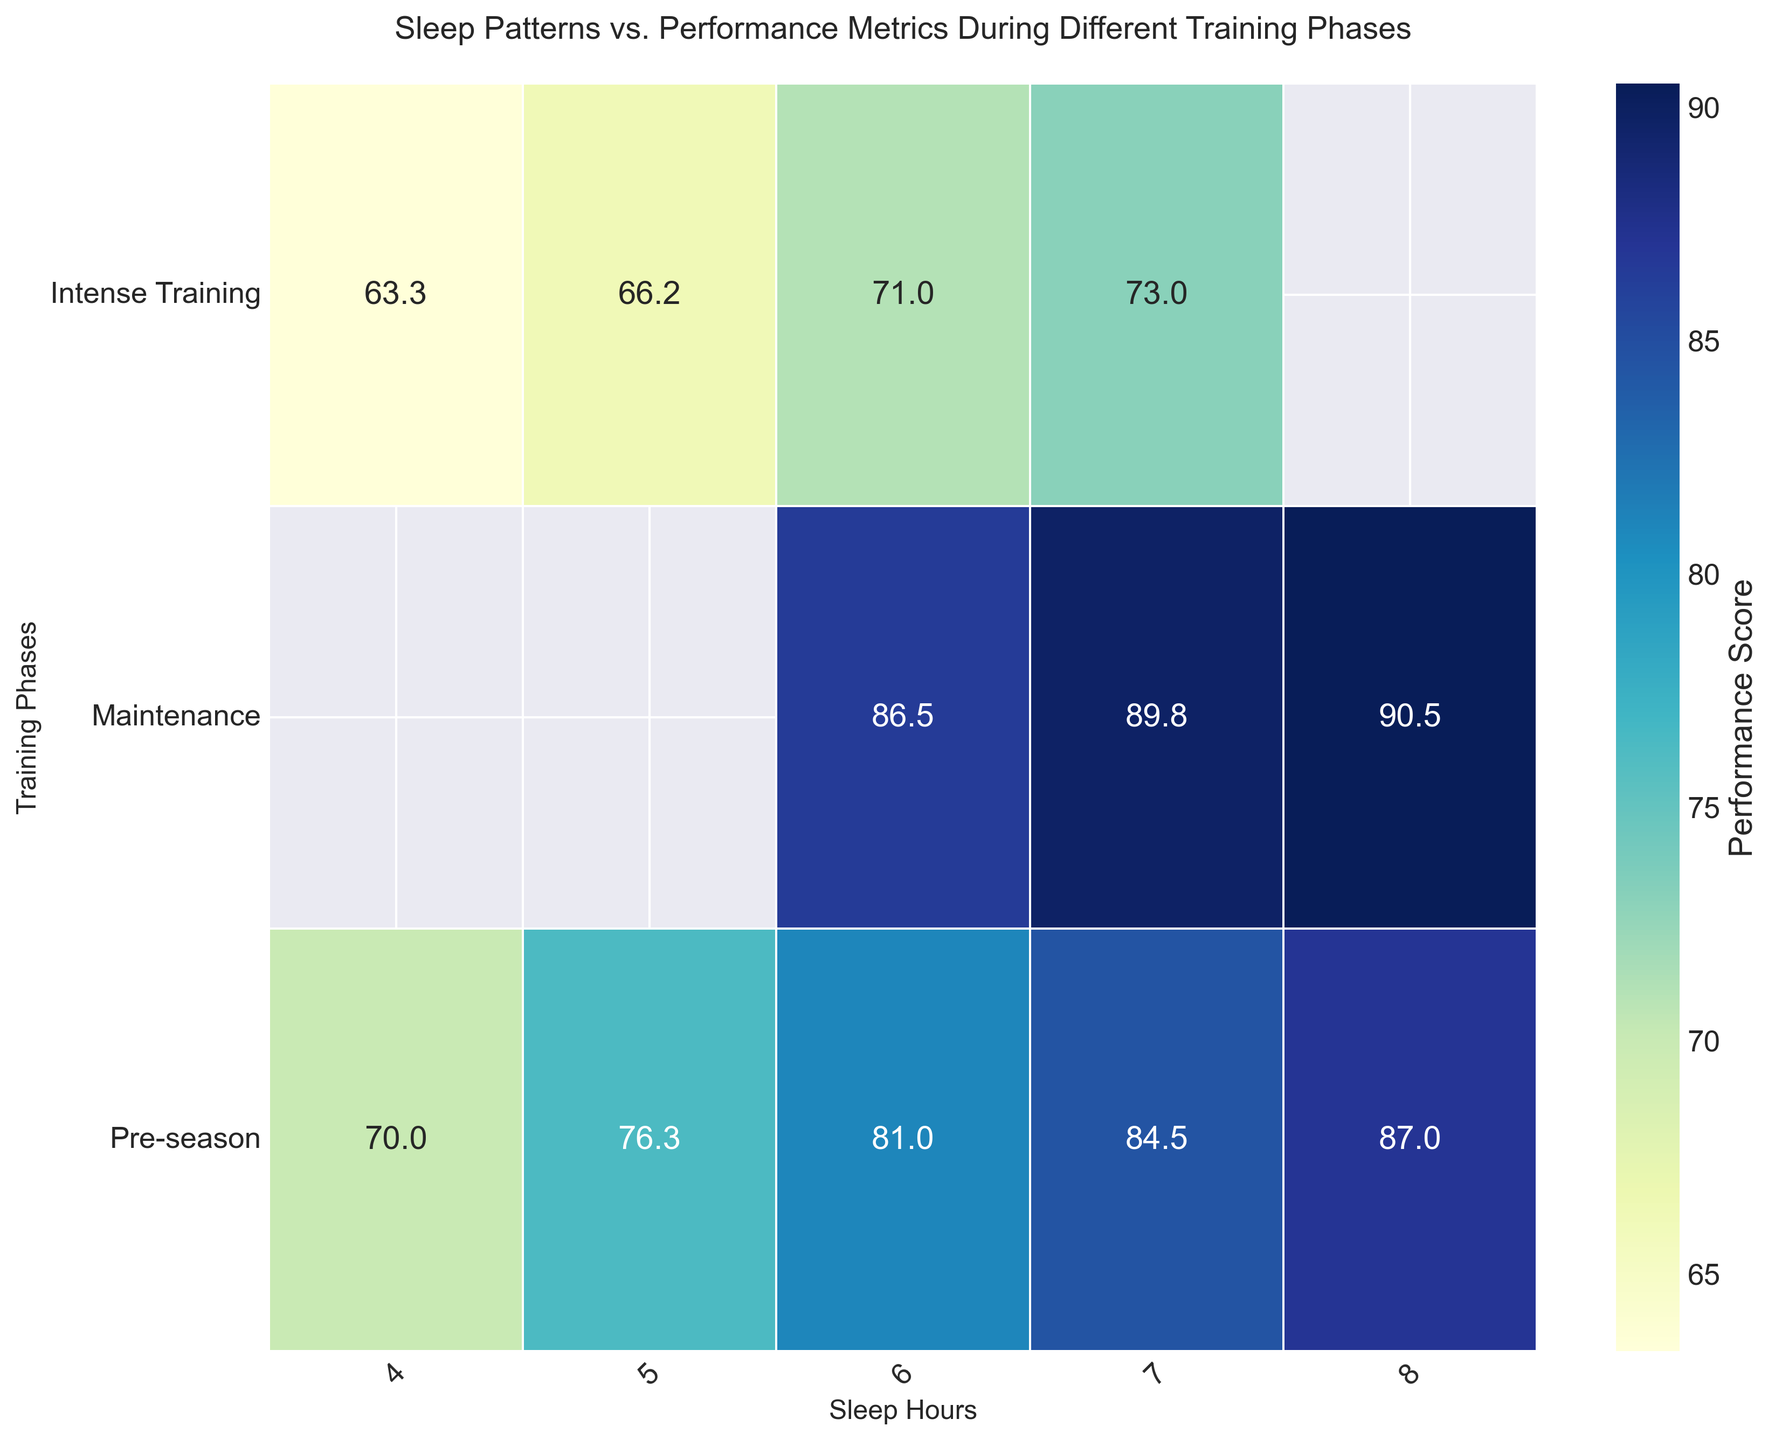How does the performance score change with sleep hours during the pre-season phase? During the pre-season phase, the performance score tends to increase with more sleep. For example, at 5 hours of sleep, the performance score is around 76.0, at 6 hours it increases to about 80.8, and at 7 hours it further increases to 84.5.
Answer: It increases Which phase has the highest average performance score at 7 hours of sleep? By looking at the heatmap, the maintenance phase has the highest performance score at 7 hours of sleep with a value of 89.8. In comparison, the pre-season score at 7 hours is 84.5, and intense training is 73.0.
Answer: Maintenance Compare the performance scores for 6 hours of sleep across different training phases. In the heatmap, pre-season has a score of 80.8, intense training has a score of 67.5, and maintenance has a score of 86.5 for 6 hours of sleep. Comparing these scores, maintenance is the highest, followed by pre-season, and intense training has the lowest score.
Answer: Maintenance > Pre-season > Intense Training What is the average performance score during the intense training phase? To calculate the average for the intense training phase, add the performance scores for different sleep hours (4 hours = 63.3, 5 hours = 66.3, 6 hours = 67.5, 7 hours = 73.0) and divide by the number of data points: (63.3 + 66.3 + 67.5 + 73.0)/4 = 67.5
Answer: 67.5 During which phase and at how many hours of sleep does the highest performance score occur? The highest performance score is 90.8, which is observed during the maintenance phase at 8 hours of sleep. This can be deduced from the darkest colored cell in the heatmap with the highest annotation.
Answer: Maintenance at 8 hours Is there any phase where a lower number of sleep hours correlates with a higher performance score than a higher number of sleep hours within the same phase? No, in all phases, an increase in sleep hours is associated with an increase or at least consistent higher performance scores. For example, in intense training, performance scores increase from 63.3 at 4 hours to 73.0 at 7 hours.
Answer: No Compare the visual intensity of the color for 6 hours of sleep across all the phases. Which phase stands out and why? The color intensity for 6 hours of sleep is darkest in the maintenance phase, indicating the highest performance score (86.5). In comparison, the pre-season phase has a moderate intensity (80.8), and the intense training phase has the lightest color (67.5), indicating the lowest performance score.
Answer: Maintenance stands out due to the darkest color indicating the highest performance score Identify the trend of performance scores for the maintenance phase as sleep increases from 6 to 8 hours. The performance scores in the maintenance phase show an increasing trend with sleep: at 6 hours the score is 86.5, at 7 hours it is 89.8, and at 8 hours it reaches 90.8. This upward trend is visible in the heatmap as the cell colors darken progressively from 6 to 8 hours.
Answer: Increasing trend 